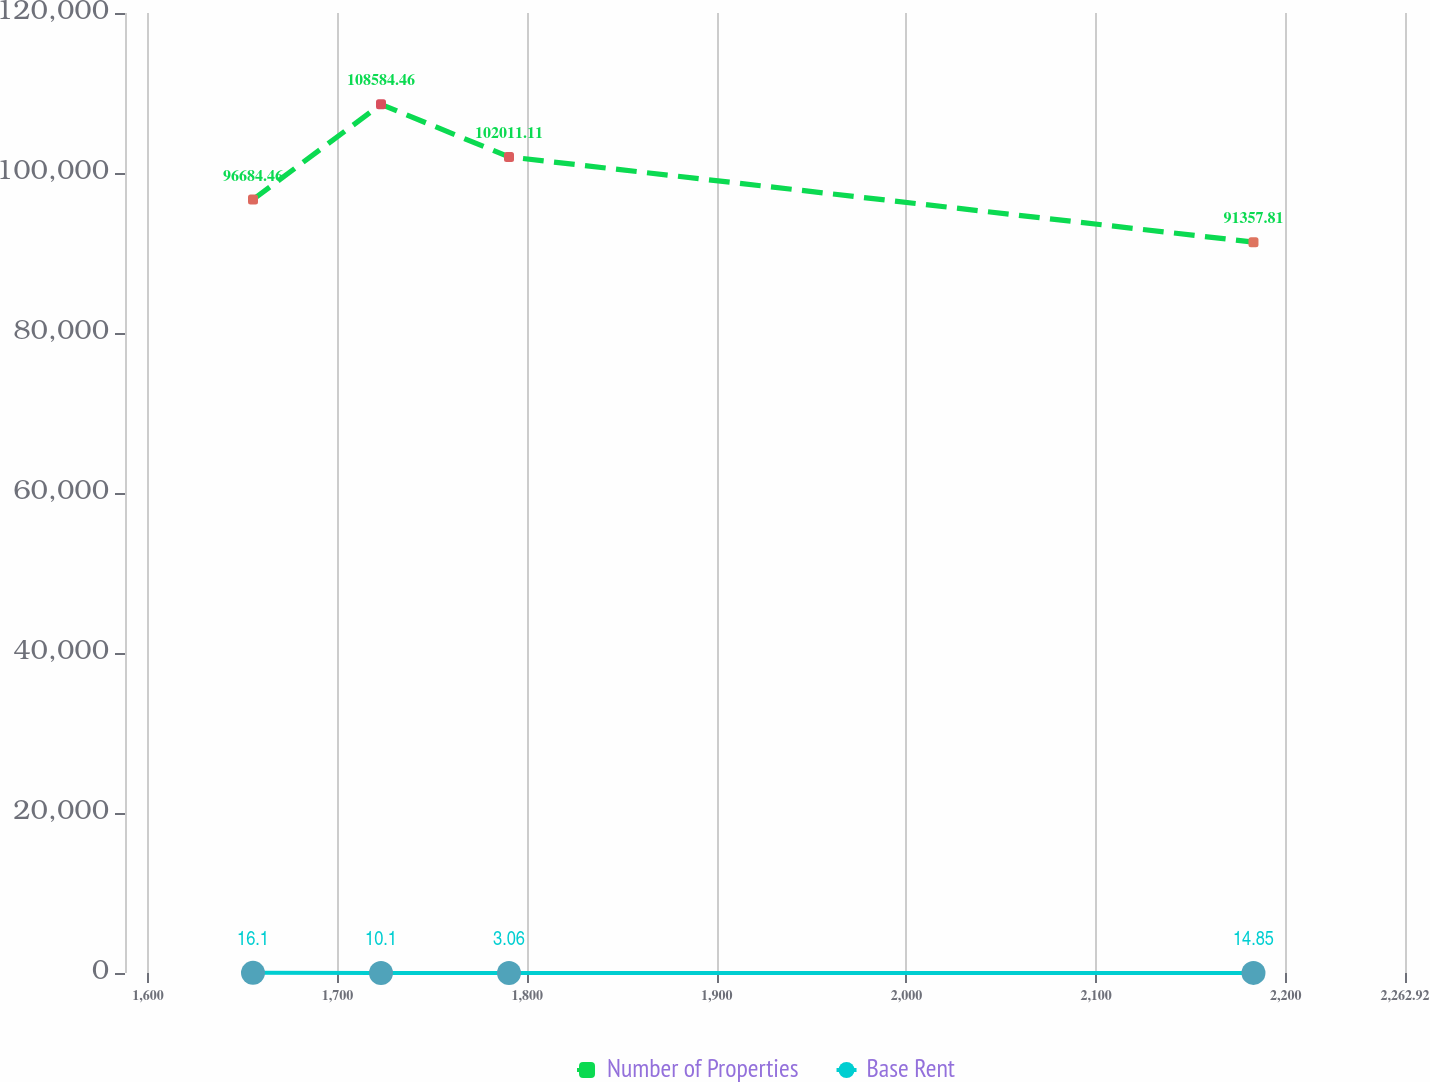Convert chart. <chart><loc_0><loc_0><loc_500><loc_500><line_chart><ecel><fcel>Number of Properties<fcel>Base Rent<nl><fcel>1655.42<fcel>96684.5<fcel>16.1<nl><fcel>1722.92<fcel>108584<fcel>10.1<nl><fcel>1790.42<fcel>102011<fcel>3.06<nl><fcel>2183.01<fcel>91357.8<fcel>14.85<nl><fcel>2330.42<fcel>55318<fcel>12.29<nl></chart> 